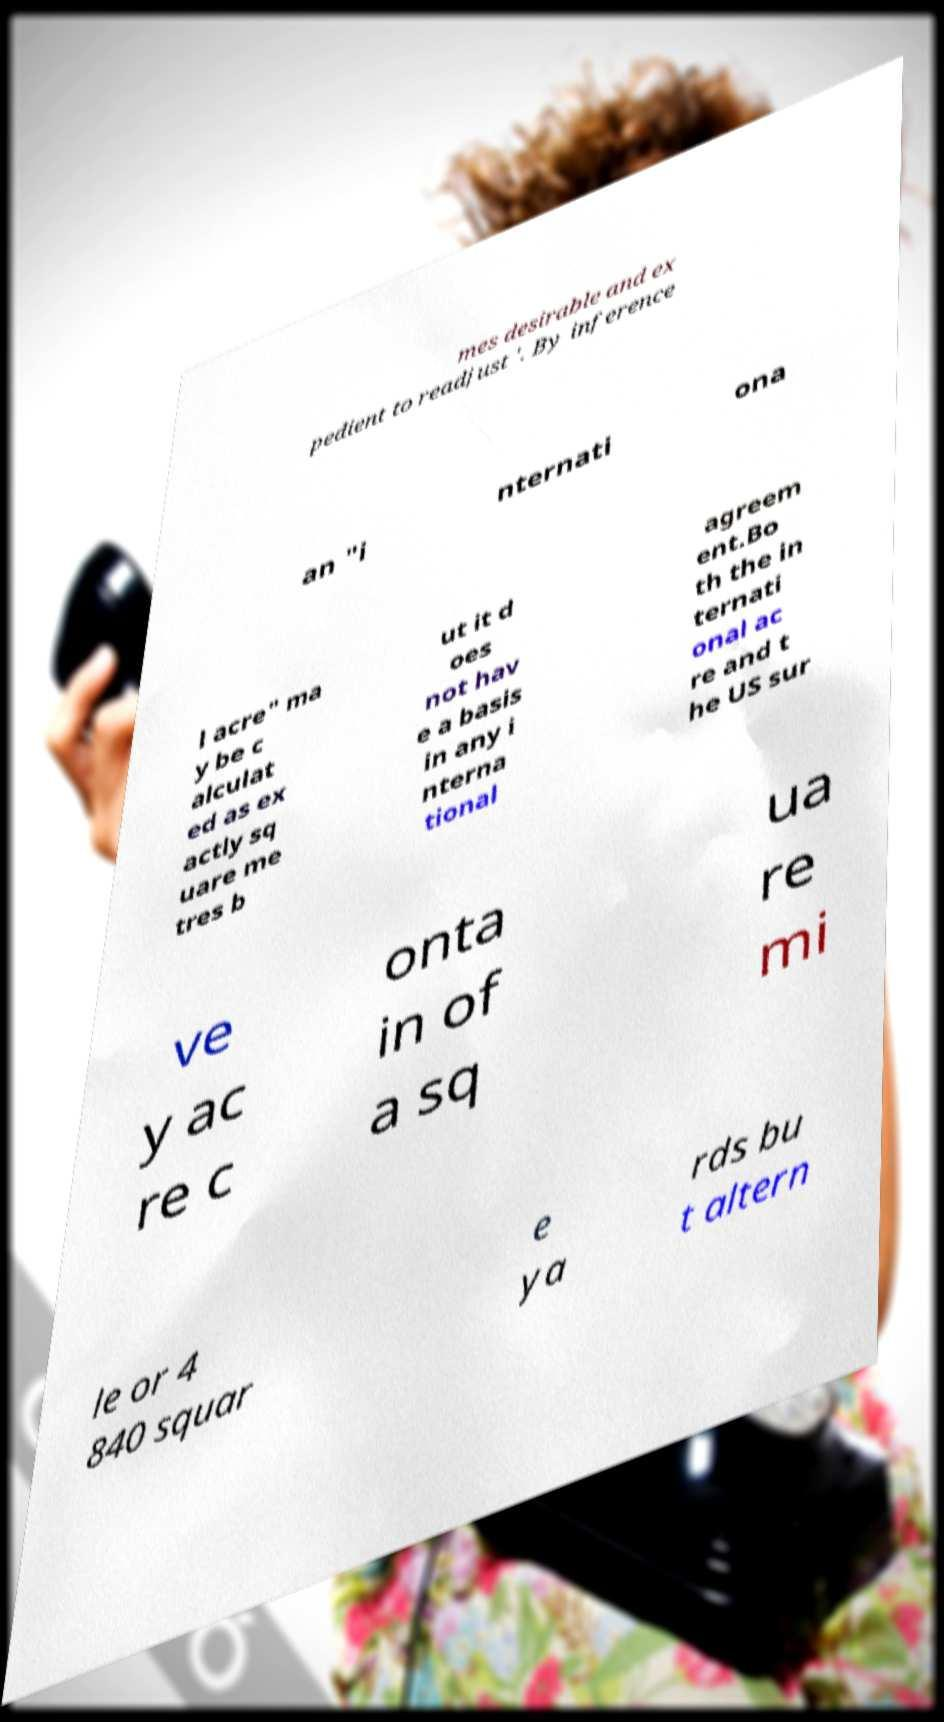For documentation purposes, I need the text within this image transcribed. Could you provide that? mes desirable and ex pedient to readjust '. By inference an "i nternati ona l acre" ma y be c alculat ed as ex actly sq uare me tres b ut it d oes not hav e a basis in any i nterna tional agreem ent.Bo th the in ternati onal ac re and t he US sur ve y ac re c onta in of a sq ua re mi le or 4 840 squar e ya rds bu t altern 